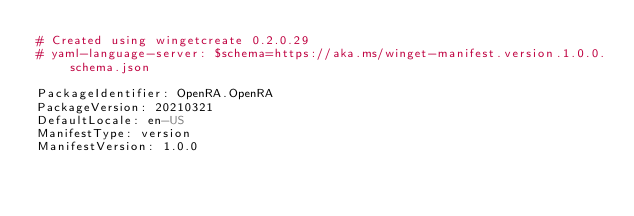Convert code to text. <code><loc_0><loc_0><loc_500><loc_500><_YAML_># Created using wingetcreate 0.2.0.29
# yaml-language-server: $schema=https://aka.ms/winget-manifest.version.1.0.0.schema.json

PackageIdentifier: OpenRA.OpenRA
PackageVersion: 20210321
DefaultLocale: en-US
ManifestType: version
ManifestVersion: 1.0.0

</code> 